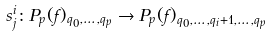<formula> <loc_0><loc_0><loc_500><loc_500>s ^ { i } _ { j } \colon P _ { p } ( f ) _ { q _ { 0 } , \dots , q _ { p } } \to { P _ { p } ( f ) _ { q _ { 0 } , \dots , q _ { i } + 1 , \dots , q _ { p } } }</formula> 